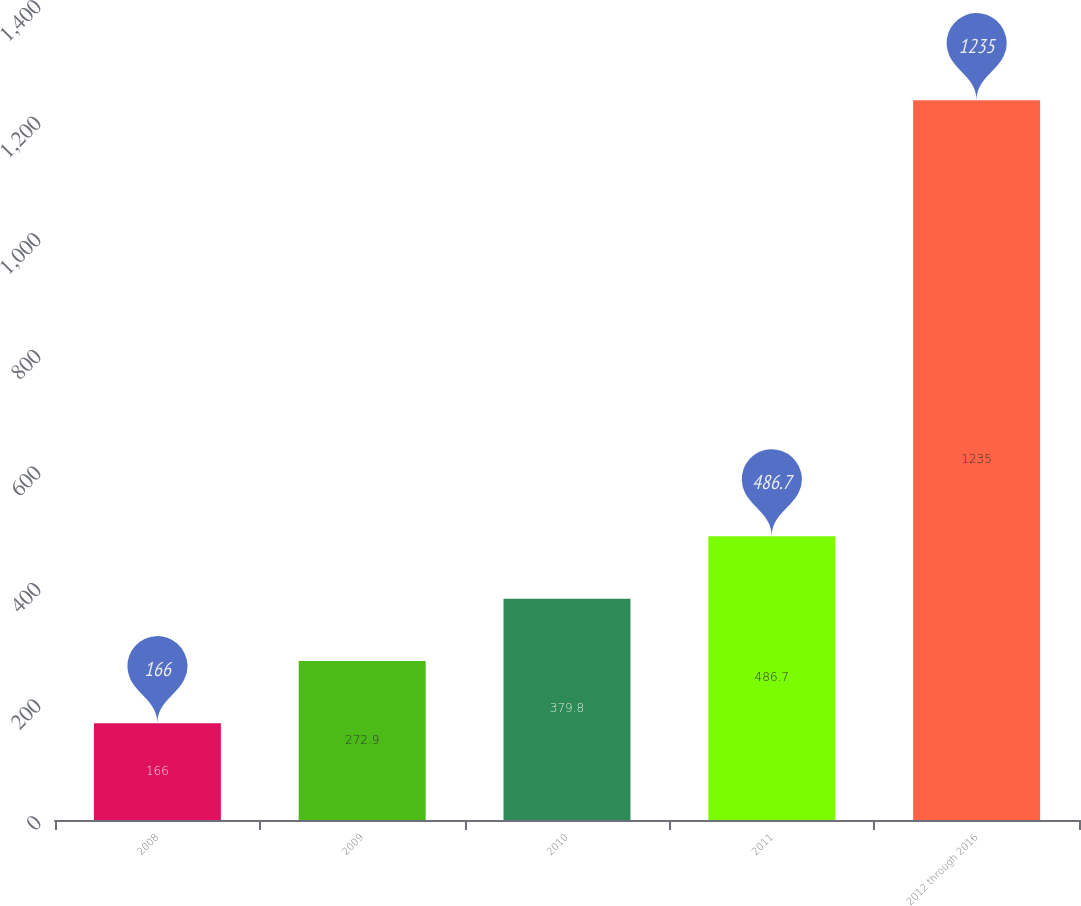Convert chart. <chart><loc_0><loc_0><loc_500><loc_500><bar_chart><fcel>2008<fcel>2009<fcel>2010<fcel>2011<fcel>2012 through 2016<nl><fcel>166<fcel>272.9<fcel>379.8<fcel>486.7<fcel>1235<nl></chart> 